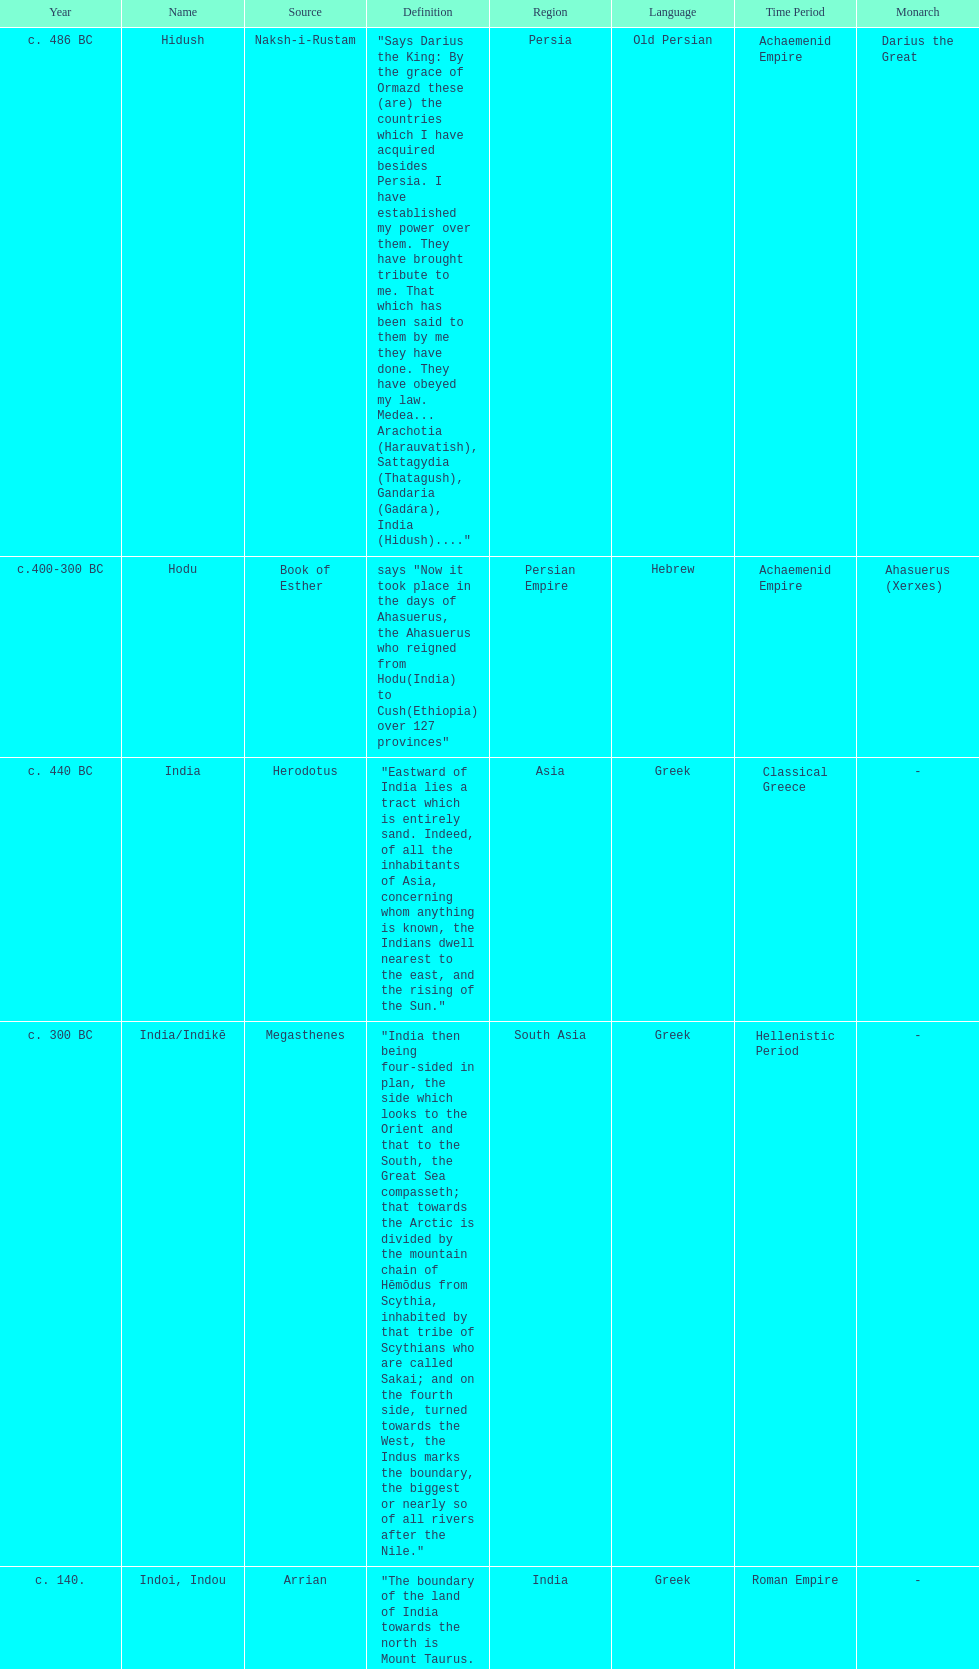Which is the most recent source for the name? Clavijo. 